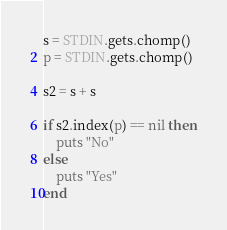Convert code to text. <code><loc_0><loc_0><loc_500><loc_500><_Ruby_>s = STDIN.gets.chomp()
p = STDIN.gets.chomp()

s2 = s + s

if s2.index(p) == nil then
    puts "No"
else
    puts "Yes"
end</code> 